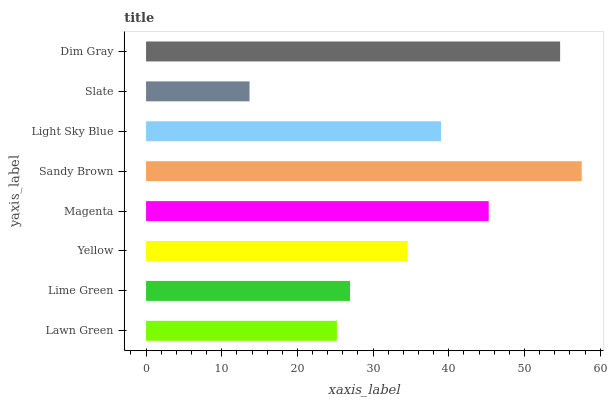Is Slate the minimum?
Answer yes or no. Yes. Is Sandy Brown the maximum?
Answer yes or no. Yes. Is Lime Green the minimum?
Answer yes or no. No. Is Lime Green the maximum?
Answer yes or no. No. Is Lime Green greater than Lawn Green?
Answer yes or no. Yes. Is Lawn Green less than Lime Green?
Answer yes or no. Yes. Is Lawn Green greater than Lime Green?
Answer yes or no. No. Is Lime Green less than Lawn Green?
Answer yes or no. No. Is Light Sky Blue the high median?
Answer yes or no. Yes. Is Yellow the low median?
Answer yes or no. Yes. Is Sandy Brown the high median?
Answer yes or no. No. Is Slate the low median?
Answer yes or no. No. 